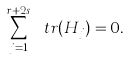<formula> <loc_0><loc_0><loc_500><loc_500>\sum _ { j = 1 } ^ { r + 2 s } \ t r ( H _ { j } ) = 0 .</formula> 